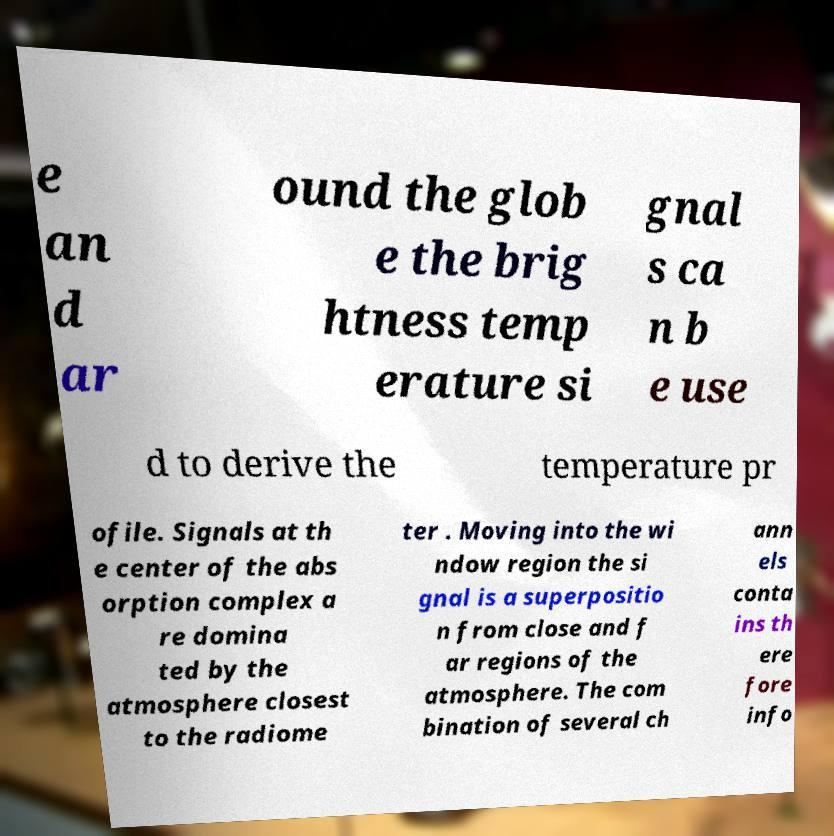I need the written content from this picture converted into text. Can you do that? e an d ar ound the glob e the brig htness temp erature si gnal s ca n b e use d to derive the temperature pr ofile. Signals at th e center of the abs orption complex a re domina ted by the atmosphere closest to the radiome ter . Moving into the wi ndow region the si gnal is a superpositio n from close and f ar regions of the atmosphere. The com bination of several ch ann els conta ins th ere fore info 